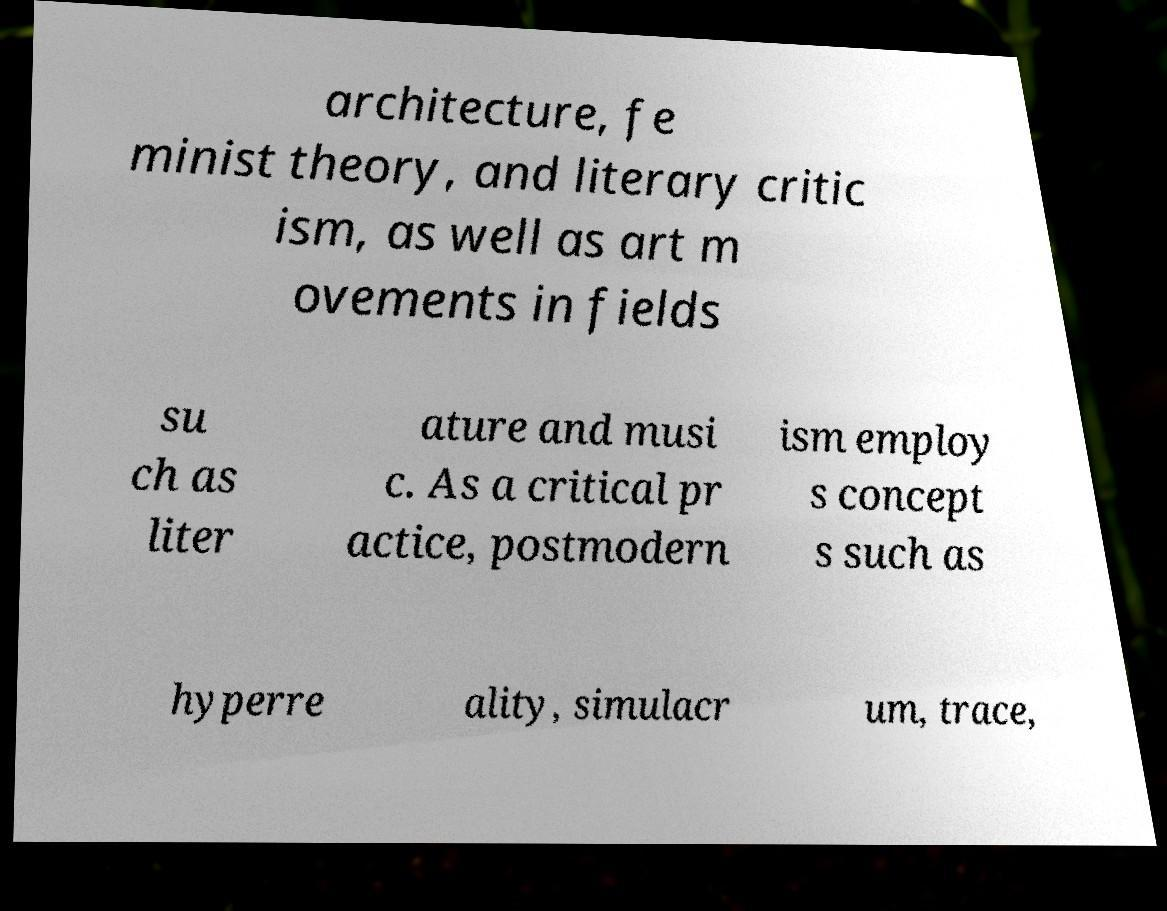I need the written content from this picture converted into text. Can you do that? architecture, fe minist theory, and literary critic ism, as well as art m ovements in fields su ch as liter ature and musi c. As a critical pr actice, postmodern ism employ s concept s such as hyperre ality, simulacr um, trace, 